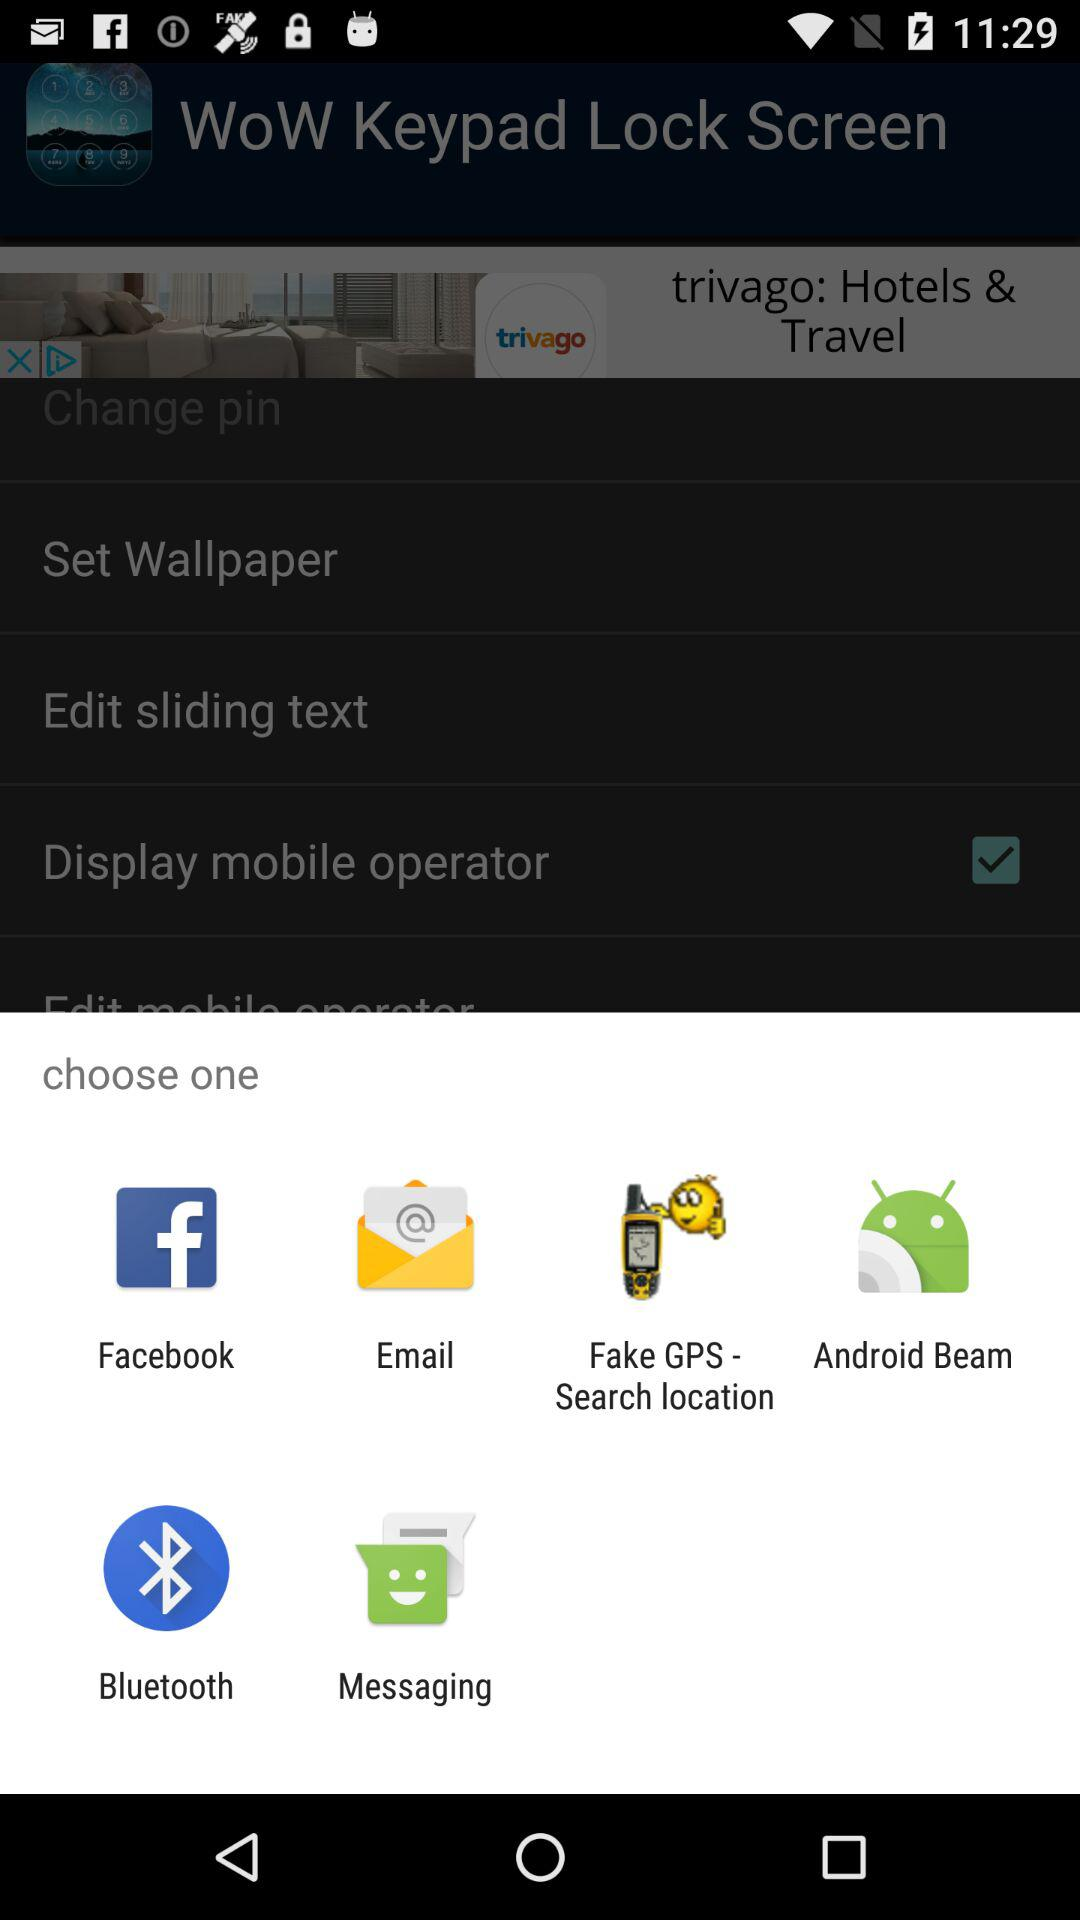What is the number of options that can be chosen? The number of options that can be chosen is one. 